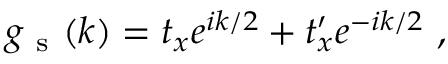Convert formula to latex. <formula><loc_0><loc_0><loc_500><loc_500>g _ { s } ( k ) = t _ { x } e ^ { i k / 2 } + t _ { x } ^ { \prime } e ^ { - i k / 2 } ,</formula> 